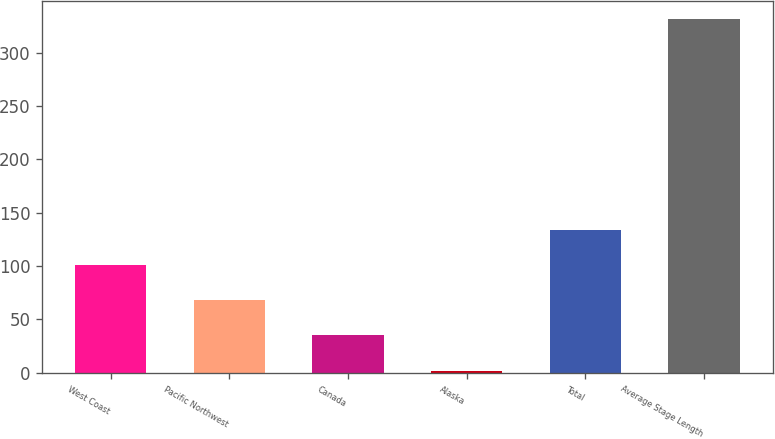<chart> <loc_0><loc_0><loc_500><loc_500><bar_chart><fcel>West Coast<fcel>Pacific Northwest<fcel>Canada<fcel>Alaska<fcel>Total<fcel>Average Stage Length<nl><fcel>101<fcel>68<fcel>35<fcel>2<fcel>134<fcel>332<nl></chart> 